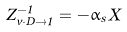<formula> <loc_0><loc_0><loc_500><loc_500>Z _ { v \cdot D \to \hat { 1 } } ^ { - 1 } = - \alpha _ { s } \, X</formula> 